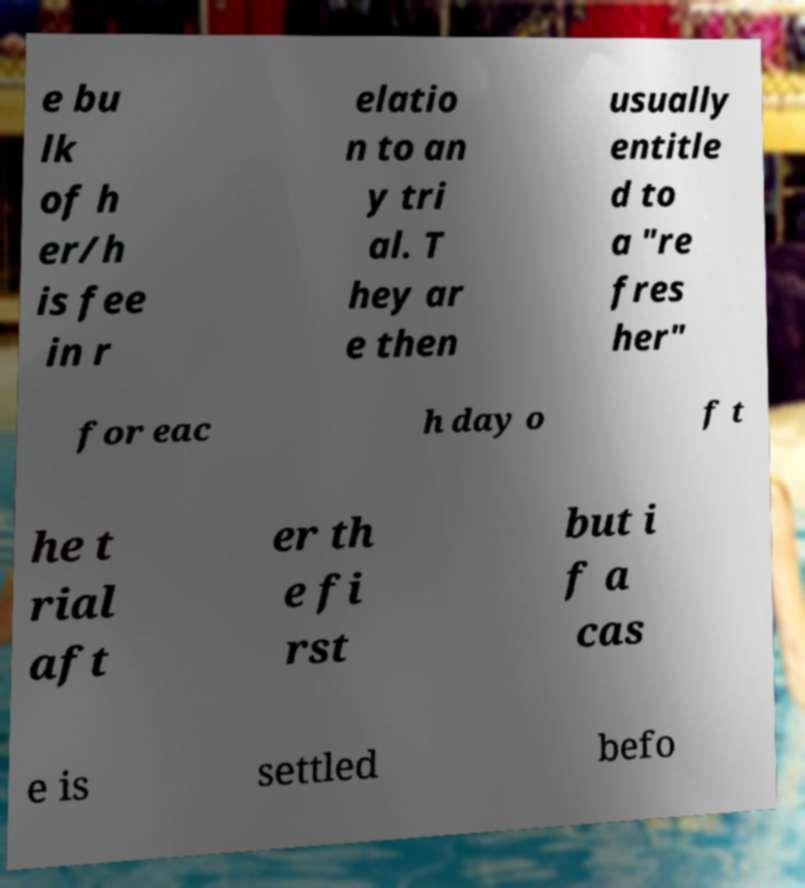Please read and relay the text visible in this image. What does it say? e bu lk of h er/h is fee in r elatio n to an y tri al. T hey ar e then usually entitle d to a "re fres her" for eac h day o f t he t rial aft er th e fi rst but i f a cas e is settled befo 